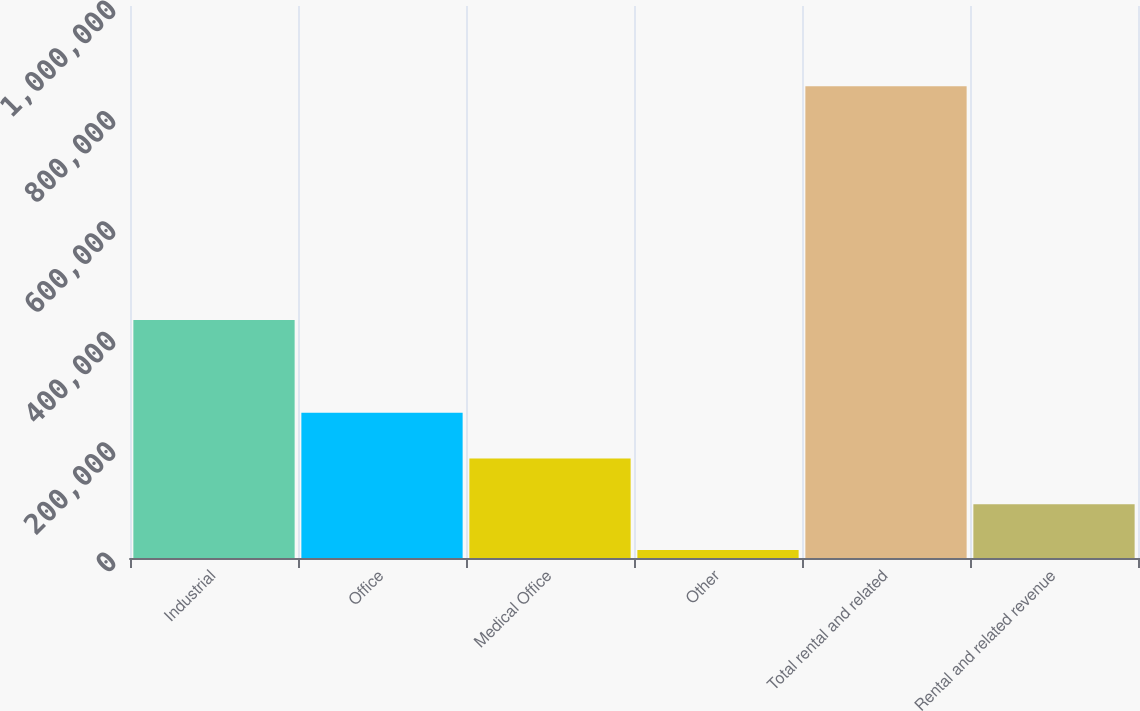Convert chart. <chart><loc_0><loc_0><loc_500><loc_500><bar_chart><fcel>Industrial<fcel>Office<fcel>Medical Office<fcel>Other<fcel>Total rental and related<fcel>Rental and related revenue<nl><fcel>431277<fcel>263063<fcel>180264<fcel>14667<fcel>854424<fcel>97465.6<nl></chart> 